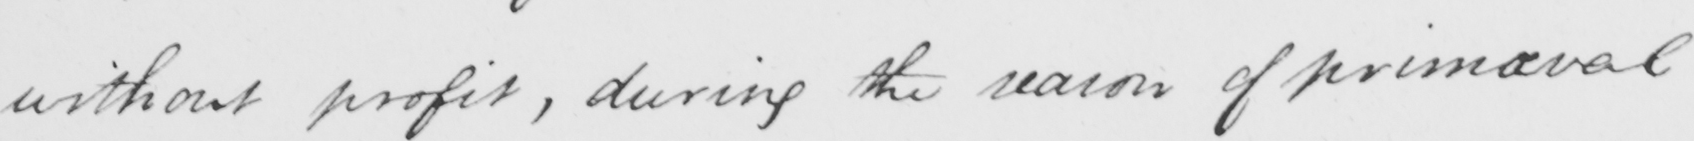What is written in this line of handwriting? without profit , during the season of primaeval 